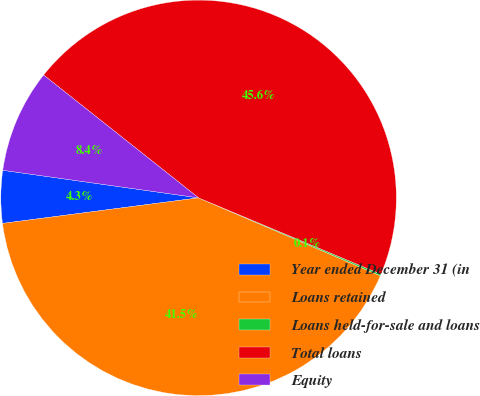<chart> <loc_0><loc_0><loc_500><loc_500><pie_chart><fcel>Year ended December 31 (in<fcel>Loans retained<fcel>Loans held-for-sale and loans<fcel>Total loans<fcel>Equity<nl><fcel>4.29%<fcel>41.49%<fcel>0.14%<fcel>45.64%<fcel>8.44%<nl></chart> 